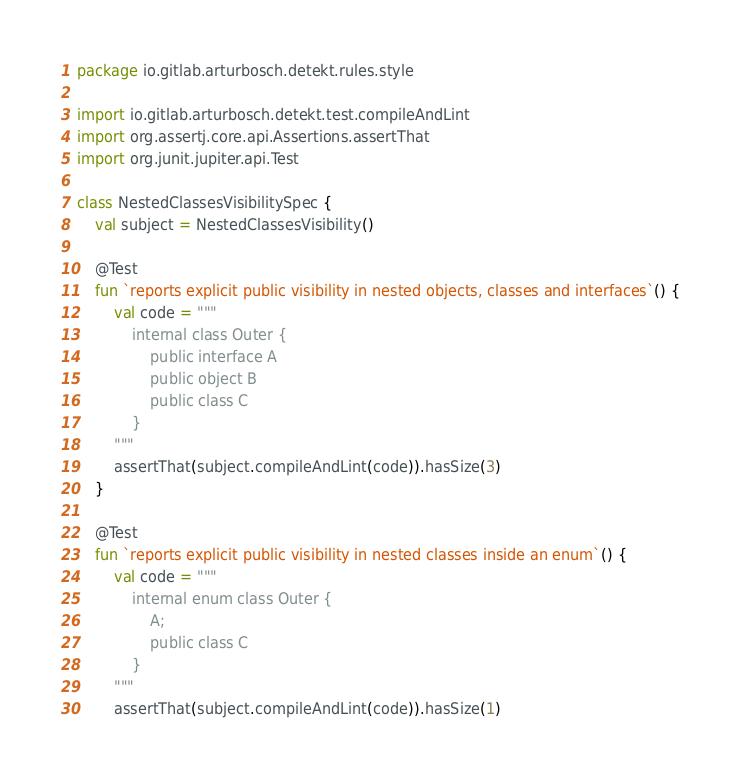Convert code to text. <code><loc_0><loc_0><loc_500><loc_500><_Kotlin_>package io.gitlab.arturbosch.detekt.rules.style

import io.gitlab.arturbosch.detekt.test.compileAndLint
import org.assertj.core.api.Assertions.assertThat
import org.junit.jupiter.api.Test

class NestedClassesVisibilitySpec {
    val subject = NestedClassesVisibility()

    @Test
    fun `reports explicit public visibility in nested objects, classes and interfaces`() {
        val code = """
            internal class Outer {
                public interface A
                public object B
                public class C
            }
        """
        assertThat(subject.compileAndLint(code)).hasSize(3)
    }

    @Test
    fun `reports explicit public visibility in nested classes inside an enum`() {
        val code = """
            internal enum class Outer {
                A;
                public class C
            }
        """
        assertThat(subject.compileAndLint(code)).hasSize(1)</code> 